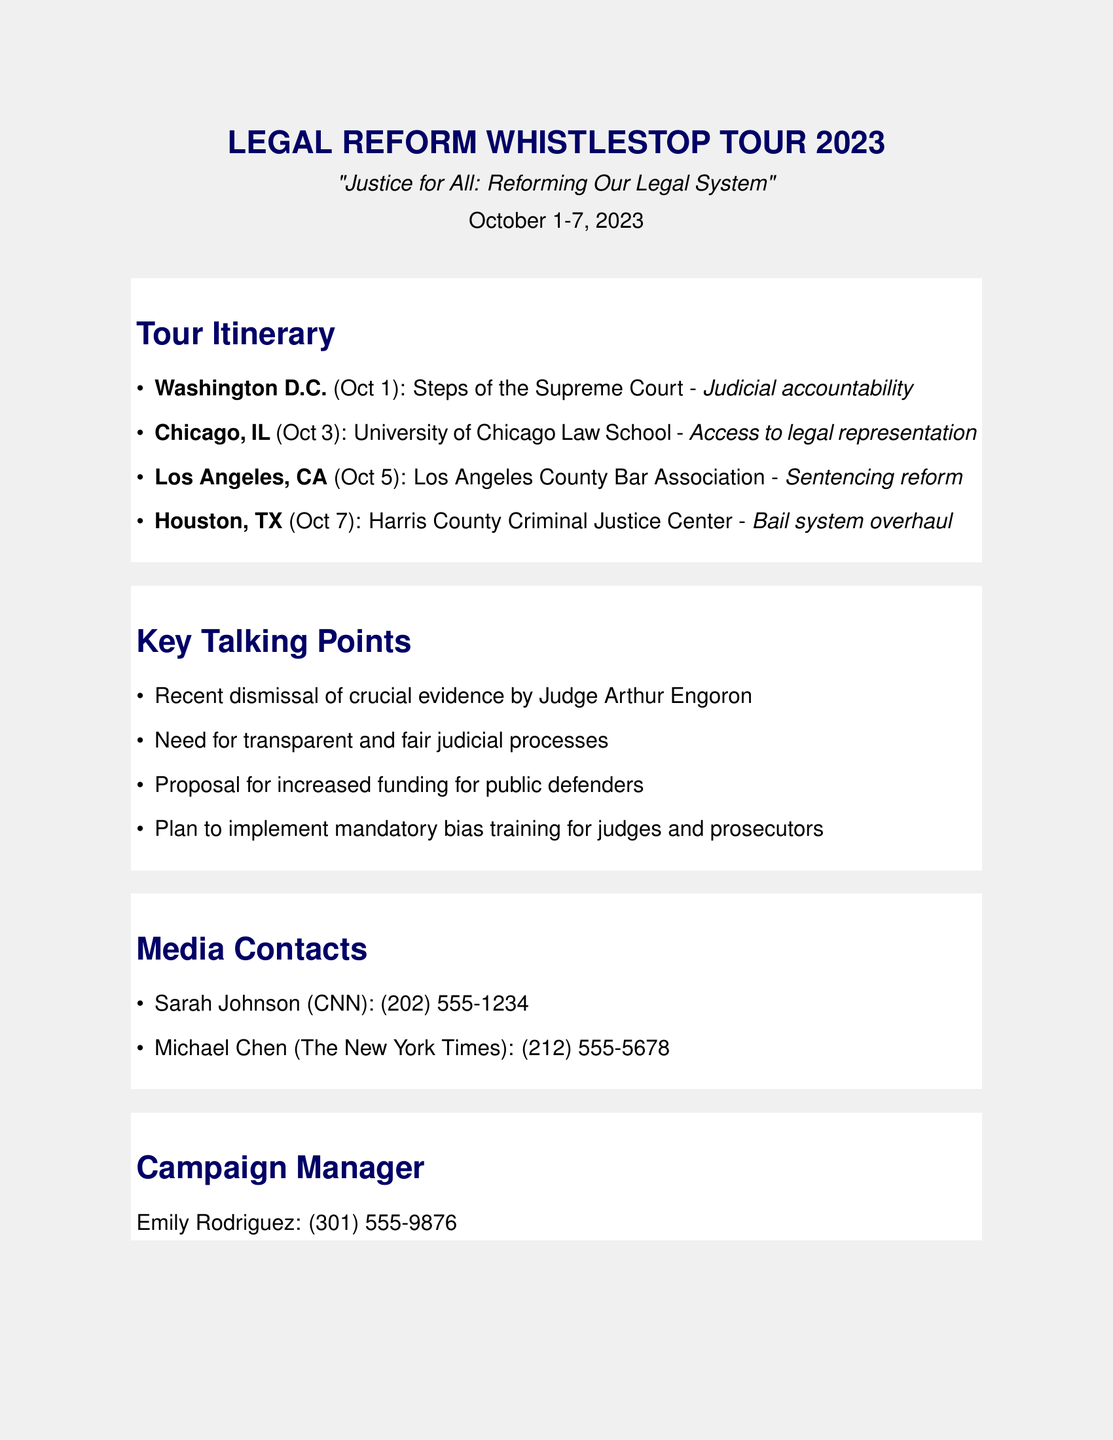What is the title of the tour? The title is mentioned at the top of the document, which is "LEGAL REFORM WHISTLESTOP TOUR 2023."
Answer: LEGAL REFORM WHISTLESTOP TOUR 2023 What is the date of the event? The date range for the event is clearly stated in the header as "October 1-7, 2023."
Answer: October 1-7, 2023 Which city has an event on October 3? The city with an event on this date is listed in the itinerary section.
Answer: Chicago, IL What is the main topic discussed in Los Angeles? The topic for the Los Angeles event is specified in the itinerary section, which focuses on sentencing reform.
Answer: Sentencing reform Who should be contacted for media inquiries? Contact names and details for media inquiries are provided in the document.
Answer: Sarah Johnson (CNN) What is one of the key talking points of the tour? The document lists several key talking points, one of which is the recent dismissal of evidence by Judge Arthur Engoron.
Answer: Recent dismissal of crucial evidence by Judge Arthur Engoron How many cities are included in the itinerary? The document outlines a total of four cities in the itinerary.
Answer: Four cities Who is the campaign manager? The campaign manager's name and contact details are listed in the document.
Answer: Emily Rodriguez What is the focus of the event in Washington D.C.? The focus is stated in the itinerary as judicial accountability.
Answer: Judicial accountability 